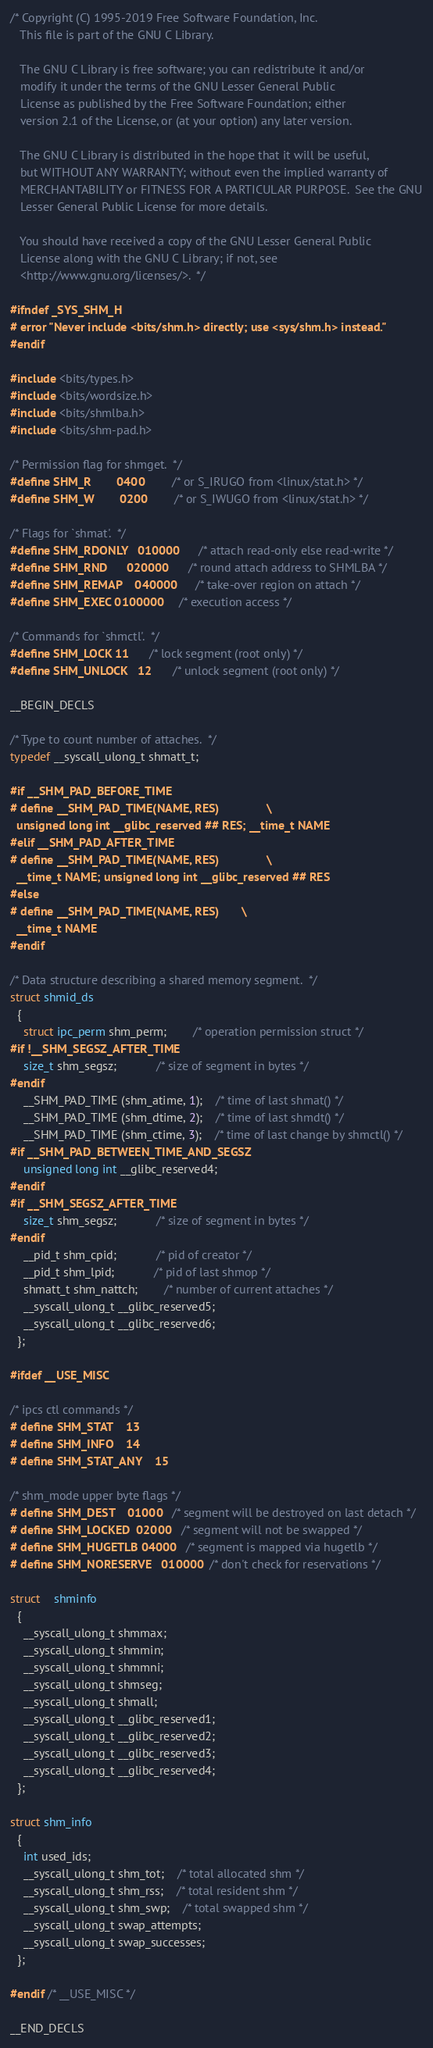Convert code to text. <code><loc_0><loc_0><loc_500><loc_500><_C_>/* Copyright (C) 1995-2019 Free Software Foundation, Inc.
   This file is part of the GNU C Library.

   The GNU C Library is free software; you can redistribute it and/or
   modify it under the terms of the GNU Lesser General Public
   License as published by the Free Software Foundation; either
   version 2.1 of the License, or (at your option) any later version.

   The GNU C Library is distributed in the hope that it will be useful,
   but WITHOUT ANY WARRANTY; without even the implied warranty of
   MERCHANTABILITY or FITNESS FOR A PARTICULAR PURPOSE.  See the GNU
   Lesser General Public License for more details.

   You should have received a copy of the GNU Lesser General Public
   License along with the GNU C Library; if not, see
   <http://www.gnu.org/licenses/>.  */

#ifndef _SYS_SHM_H
# error "Never include <bits/shm.h> directly; use <sys/shm.h> instead."
#endif

#include <bits/types.h>
#include <bits/wordsize.h>
#include <bits/shmlba.h>
#include <bits/shm-pad.h>

/* Permission flag for shmget.  */
#define SHM_R		0400		/* or S_IRUGO from <linux/stat.h> */
#define SHM_W		0200		/* or S_IWUGO from <linux/stat.h> */

/* Flags for `shmat'.  */
#define SHM_RDONLY	010000		/* attach read-only else read-write */
#define SHM_RND		020000		/* round attach address to SHMLBA */
#define SHM_REMAP	040000		/* take-over region on attach */
#define SHM_EXEC	0100000		/* execution access */

/* Commands for `shmctl'.  */
#define SHM_LOCK	11		/* lock segment (root only) */
#define SHM_UNLOCK	12		/* unlock segment (root only) */

__BEGIN_DECLS

/* Type to count number of attaches.  */
typedef __syscall_ulong_t shmatt_t;

#if __SHM_PAD_BEFORE_TIME
# define __SHM_PAD_TIME(NAME, RES)				\
  unsigned long int __glibc_reserved ## RES; __time_t NAME
#elif __SHM_PAD_AFTER_TIME
# define __SHM_PAD_TIME(NAME, RES)				\
  __time_t NAME; unsigned long int __glibc_reserved ## RES
#else
# define __SHM_PAD_TIME(NAME, RES)		\
  __time_t NAME
#endif

/* Data structure describing a shared memory segment.  */
struct shmid_ds
  {
    struct ipc_perm shm_perm;		/* operation permission struct */
#if !__SHM_SEGSZ_AFTER_TIME
    size_t shm_segsz;			/* size of segment in bytes */
#endif
    __SHM_PAD_TIME (shm_atime, 1);	/* time of last shmat() */
    __SHM_PAD_TIME (shm_dtime, 2);	/* time of last shmdt() */
    __SHM_PAD_TIME (shm_ctime, 3);	/* time of last change by shmctl() */
#if __SHM_PAD_BETWEEN_TIME_AND_SEGSZ
    unsigned long int __glibc_reserved4;
#endif
#if __SHM_SEGSZ_AFTER_TIME
    size_t shm_segsz;			/* size of segment in bytes */
#endif
    __pid_t shm_cpid;			/* pid of creator */
    __pid_t shm_lpid;			/* pid of last shmop */
    shmatt_t shm_nattch;		/* number of current attaches */
    __syscall_ulong_t __glibc_reserved5;
    __syscall_ulong_t __glibc_reserved6;
  };

#ifdef __USE_MISC

/* ipcs ctl commands */
# define SHM_STAT 	13
# define SHM_INFO 	14
# define SHM_STAT_ANY	15

/* shm_mode upper byte flags */
# define SHM_DEST	01000	/* segment will be destroyed on last detach */
# define SHM_LOCKED	02000   /* segment will not be swapped */
# define SHM_HUGETLB	04000	/* segment is mapped via hugetlb */
# define SHM_NORESERVE	010000	/* don't check for reservations */

struct	shminfo
  {
    __syscall_ulong_t shmmax;
    __syscall_ulong_t shmmin;
    __syscall_ulong_t shmmni;
    __syscall_ulong_t shmseg;
    __syscall_ulong_t shmall;
    __syscall_ulong_t __glibc_reserved1;
    __syscall_ulong_t __glibc_reserved2;
    __syscall_ulong_t __glibc_reserved3;
    __syscall_ulong_t __glibc_reserved4;
  };

struct shm_info
  {
    int used_ids;
    __syscall_ulong_t shm_tot;	/* total allocated shm */
    __syscall_ulong_t shm_rss;	/* total resident shm */
    __syscall_ulong_t shm_swp;	/* total swapped shm */
    __syscall_ulong_t swap_attempts;
    __syscall_ulong_t swap_successes;
  };

#endif /* __USE_MISC */

__END_DECLS
</code> 